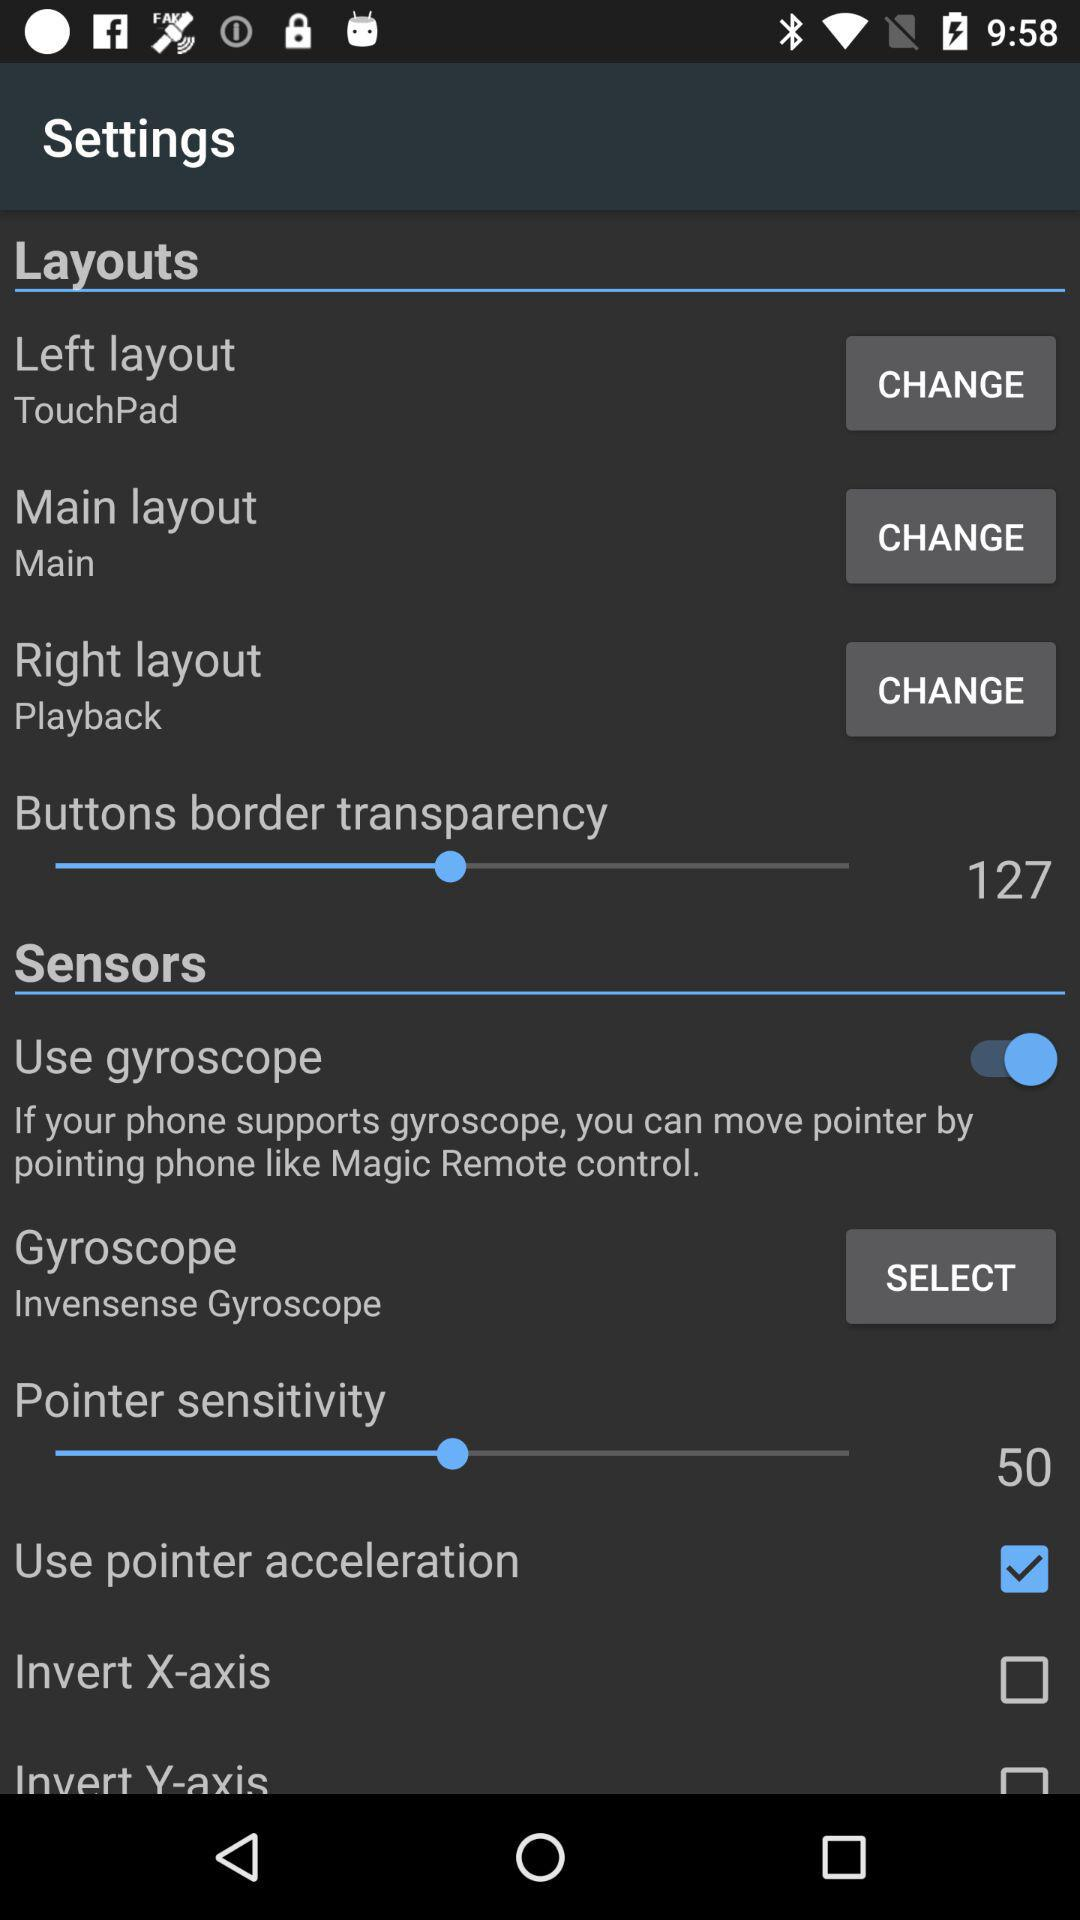What is the setting for the left layout? The setting is "TouchPad". 